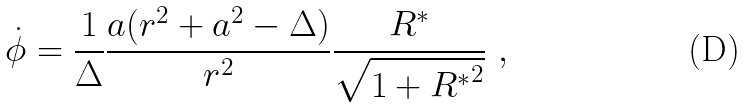<formula> <loc_0><loc_0><loc_500><loc_500>\dot { \phi } = \frac { 1 } { \Delta } \frac { a ( r ^ { 2 } + a ^ { 2 } - \Delta ) } { r ^ { 2 } } \frac { R ^ { * } } { \sqrt { 1 + { R ^ { \ast } } ^ { 2 } } } \ ,</formula> 